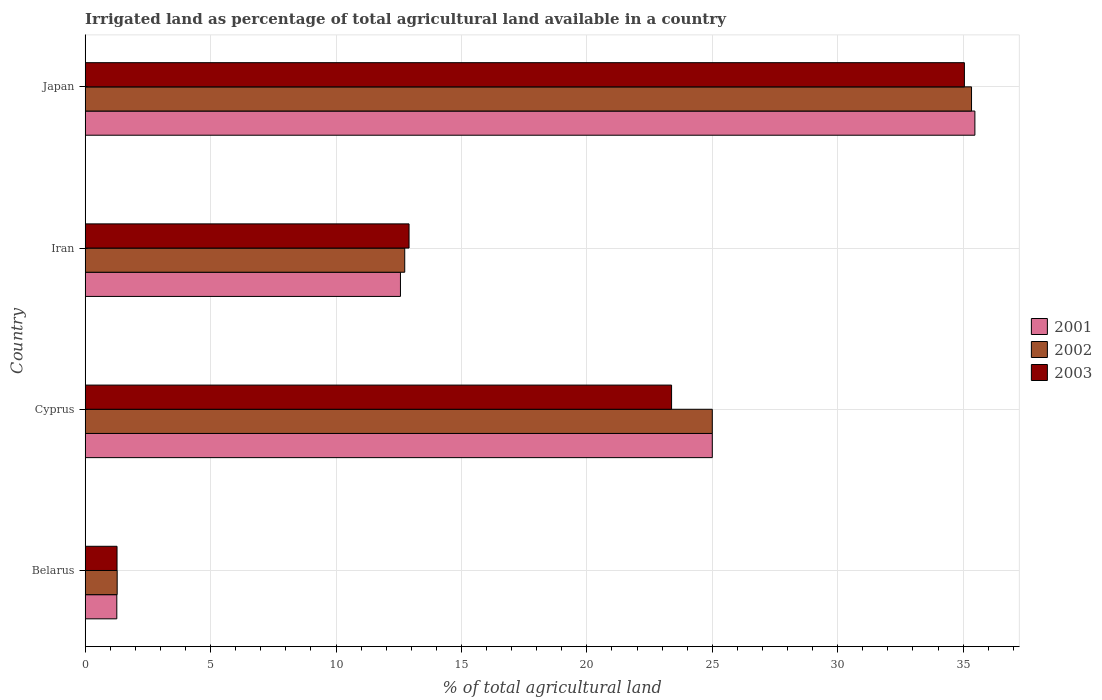How many bars are there on the 1st tick from the bottom?
Your answer should be very brief. 3. What is the label of the 2nd group of bars from the top?
Ensure brevity in your answer.  Iran. What is the percentage of irrigated land in 2001 in Belarus?
Provide a short and direct response. 1.26. Across all countries, what is the maximum percentage of irrigated land in 2001?
Make the answer very short. 35.47. Across all countries, what is the minimum percentage of irrigated land in 2001?
Give a very brief answer. 1.26. In which country was the percentage of irrigated land in 2003 maximum?
Ensure brevity in your answer.  Japan. In which country was the percentage of irrigated land in 2002 minimum?
Keep it short and to the point. Belarus. What is the total percentage of irrigated land in 2003 in the graph?
Ensure brevity in your answer.  72.61. What is the difference between the percentage of irrigated land in 2001 in Belarus and that in Japan?
Provide a succinct answer. -34.21. What is the difference between the percentage of irrigated land in 2001 in Belarus and the percentage of irrigated land in 2003 in Cyprus?
Provide a succinct answer. -22.12. What is the average percentage of irrigated land in 2003 per country?
Your response must be concise. 18.15. What is the difference between the percentage of irrigated land in 2002 and percentage of irrigated land in 2001 in Japan?
Your answer should be very brief. -0.13. What is the ratio of the percentage of irrigated land in 2002 in Cyprus to that in Japan?
Offer a very short reply. 0.71. Is the difference between the percentage of irrigated land in 2002 in Cyprus and Iran greater than the difference between the percentage of irrigated land in 2001 in Cyprus and Iran?
Offer a very short reply. No. What is the difference between the highest and the second highest percentage of irrigated land in 2001?
Give a very brief answer. 10.47. What is the difference between the highest and the lowest percentage of irrigated land in 2001?
Ensure brevity in your answer.  34.21. Is the sum of the percentage of irrigated land in 2001 in Cyprus and Iran greater than the maximum percentage of irrigated land in 2002 across all countries?
Keep it short and to the point. Yes. How many bars are there?
Your answer should be very brief. 12. What is the difference between two consecutive major ticks on the X-axis?
Your answer should be compact. 5. Where does the legend appear in the graph?
Your answer should be compact. Center right. How many legend labels are there?
Offer a very short reply. 3. How are the legend labels stacked?
Your answer should be very brief. Vertical. What is the title of the graph?
Your answer should be very brief. Irrigated land as percentage of total agricultural land available in a country. Does "1976" appear as one of the legend labels in the graph?
Your answer should be compact. No. What is the label or title of the X-axis?
Give a very brief answer. % of total agricultural land. What is the % of total agricultural land of 2001 in Belarus?
Give a very brief answer. 1.26. What is the % of total agricultural land of 2002 in Belarus?
Offer a very short reply. 1.27. What is the % of total agricultural land of 2003 in Belarus?
Give a very brief answer. 1.27. What is the % of total agricultural land in 2003 in Cyprus?
Ensure brevity in your answer.  23.38. What is the % of total agricultural land of 2001 in Iran?
Keep it short and to the point. 12.57. What is the % of total agricultural land of 2002 in Iran?
Give a very brief answer. 12.74. What is the % of total agricultural land of 2003 in Iran?
Give a very brief answer. 12.91. What is the % of total agricultural land of 2001 in Japan?
Your response must be concise. 35.47. What is the % of total agricultural land of 2002 in Japan?
Your answer should be very brief. 35.33. What is the % of total agricultural land of 2003 in Japan?
Keep it short and to the point. 35.05. Across all countries, what is the maximum % of total agricultural land of 2001?
Keep it short and to the point. 35.47. Across all countries, what is the maximum % of total agricultural land in 2002?
Make the answer very short. 35.33. Across all countries, what is the maximum % of total agricultural land in 2003?
Ensure brevity in your answer.  35.05. Across all countries, what is the minimum % of total agricultural land in 2001?
Your response must be concise. 1.26. Across all countries, what is the minimum % of total agricultural land of 2002?
Keep it short and to the point. 1.27. Across all countries, what is the minimum % of total agricultural land in 2003?
Your answer should be compact. 1.27. What is the total % of total agricultural land of 2001 in the graph?
Offer a very short reply. 74.3. What is the total % of total agricultural land of 2002 in the graph?
Make the answer very short. 74.35. What is the total % of total agricultural land in 2003 in the graph?
Your answer should be compact. 72.61. What is the difference between the % of total agricultural land in 2001 in Belarus and that in Cyprus?
Your response must be concise. -23.74. What is the difference between the % of total agricultural land in 2002 in Belarus and that in Cyprus?
Make the answer very short. -23.73. What is the difference between the % of total agricultural land in 2003 in Belarus and that in Cyprus?
Offer a terse response. -22.11. What is the difference between the % of total agricultural land in 2001 in Belarus and that in Iran?
Your answer should be very brief. -11.31. What is the difference between the % of total agricultural land of 2002 in Belarus and that in Iran?
Provide a succinct answer. -11.46. What is the difference between the % of total agricultural land in 2003 in Belarus and that in Iran?
Make the answer very short. -11.64. What is the difference between the % of total agricultural land in 2001 in Belarus and that in Japan?
Provide a succinct answer. -34.21. What is the difference between the % of total agricultural land in 2002 in Belarus and that in Japan?
Offer a terse response. -34.06. What is the difference between the % of total agricultural land of 2003 in Belarus and that in Japan?
Your response must be concise. -33.78. What is the difference between the % of total agricultural land in 2001 in Cyprus and that in Iran?
Give a very brief answer. 12.43. What is the difference between the % of total agricultural land of 2002 in Cyprus and that in Iran?
Provide a short and direct response. 12.26. What is the difference between the % of total agricultural land in 2003 in Cyprus and that in Iran?
Provide a short and direct response. 10.47. What is the difference between the % of total agricultural land of 2001 in Cyprus and that in Japan?
Offer a very short reply. -10.47. What is the difference between the % of total agricultural land of 2002 in Cyprus and that in Japan?
Offer a very short reply. -10.33. What is the difference between the % of total agricultural land of 2003 in Cyprus and that in Japan?
Provide a succinct answer. -11.67. What is the difference between the % of total agricultural land of 2001 in Iran and that in Japan?
Make the answer very short. -22.9. What is the difference between the % of total agricultural land of 2002 in Iran and that in Japan?
Keep it short and to the point. -22.6. What is the difference between the % of total agricultural land in 2003 in Iran and that in Japan?
Give a very brief answer. -22.14. What is the difference between the % of total agricultural land of 2001 in Belarus and the % of total agricultural land of 2002 in Cyprus?
Make the answer very short. -23.74. What is the difference between the % of total agricultural land of 2001 in Belarus and the % of total agricultural land of 2003 in Cyprus?
Your answer should be very brief. -22.12. What is the difference between the % of total agricultural land of 2002 in Belarus and the % of total agricultural land of 2003 in Cyprus?
Ensure brevity in your answer.  -22.1. What is the difference between the % of total agricultural land of 2001 in Belarus and the % of total agricultural land of 2002 in Iran?
Offer a terse response. -11.48. What is the difference between the % of total agricultural land in 2001 in Belarus and the % of total agricultural land in 2003 in Iran?
Ensure brevity in your answer.  -11.65. What is the difference between the % of total agricultural land in 2002 in Belarus and the % of total agricultural land in 2003 in Iran?
Ensure brevity in your answer.  -11.64. What is the difference between the % of total agricultural land of 2001 in Belarus and the % of total agricultural land of 2002 in Japan?
Your answer should be compact. -34.08. What is the difference between the % of total agricultural land in 2001 in Belarus and the % of total agricultural land in 2003 in Japan?
Provide a succinct answer. -33.79. What is the difference between the % of total agricultural land of 2002 in Belarus and the % of total agricultural land of 2003 in Japan?
Provide a succinct answer. -33.78. What is the difference between the % of total agricultural land in 2001 in Cyprus and the % of total agricultural land in 2002 in Iran?
Your answer should be compact. 12.26. What is the difference between the % of total agricultural land of 2001 in Cyprus and the % of total agricultural land of 2003 in Iran?
Ensure brevity in your answer.  12.09. What is the difference between the % of total agricultural land in 2002 in Cyprus and the % of total agricultural land in 2003 in Iran?
Keep it short and to the point. 12.09. What is the difference between the % of total agricultural land of 2001 in Cyprus and the % of total agricultural land of 2002 in Japan?
Give a very brief answer. -10.33. What is the difference between the % of total agricultural land of 2001 in Cyprus and the % of total agricultural land of 2003 in Japan?
Give a very brief answer. -10.05. What is the difference between the % of total agricultural land in 2002 in Cyprus and the % of total agricultural land in 2003 in Japan?
Your answer should be compact. -10.05. What is the difference between the % of total agricultural land in 2001 in Iran and the % of total agricultural land in 2002 in Japan?
Your answer should be very brief. -22.77. What is the difference between the % of total agricultural land in 2001 in Iran and the % of total agricultural land in 2003 in Japan?
Your answer should be compact. -22.48. What is the difference between the % of total agricultural land of 2002 in Iran and the % of total agricultural land of 2003 in Japan?
Provide a short and direct response. -22.31. What is the average % of total agricultural land of 2001 per country?
Your answer should be compact. 18.57. What is the average % of total agricultural land of 2002 per country?
Your response must be concise. 18.59. What is the average % of total agricultural land in 2003 per country?
Give a very brief answer. 18.15. What is the difference between the % of total agricultural land in 2001 and % of total agricultural land in 2002 in Belarus?
Your answer should be very brief. -0.01. What is the difference between the % of total agricultural land in 2001 and % of total agricultural land in 2003 in Belarus?
Provide a succinct answer. -0.01. What is the difference between the % of total agricultural land in 2002 and % of total agricultural land in 2003 in Belarus?
Provide a succinct answer. 0.01. What is the difference between the % of total agricultural land of 2001 and % of total agricultural land of 2003 in Cyprus?
Ensure brevity in your answer.  1.62. What is the difference between the % of total agricultural land in 2002 and % of total agricultural land in 2003 in Cyprus?
Your answer should be very brief. 1.62. What is the difference between the % of total agricultural land of 2001 and % of total agricultural land of 2002 in Iran?
Make the answer very short. -0.17. What is the difference between the % of total agricultural land of 2001 and % of total agricultural land of 2003 in Iran?
Keep it short and to the point. -0.34. What is the difference between the % of total agricultural land of 2002 and % of total agricultural land of 2003 in Iran?
Keep it short and to the point. -0.17. What is the difference between the % of total agricultural land of 2001 and % of total agricultural land of 2002 in Japan?
Provide a short and direct response. 0.13. What is the difference between the % of total agricultural land in 2001 and % of total agricultural land in 2003 in Japan?
Give a very brief answer. 0.42. What is the difference between the % of total agricultural land of 2002 and % of total agricultural land of 2003 in Japan?
Offer a terse response. 0.28. What is the ratio of the % of total agricultural land of 2001 in Belarus to that in Cyprus?
Keep it short and to the point. 0.05. What is the ratio of the % of total agricultural land in 2002 in Belarus to that in Cyprus?
Your answer should be very brief. 0.05. What is the ratio of the % of total agricultural land of 2003 in Belarus to that in Cyprus?
Keep it short and to the point. 0.05. What is the ratio of the % of total agricultural land of 2001 in Belarus to that in Iran?
Your answer should be compact. 0.1. What is the ratio of the % of total agricultural land of 2003 in Belarus to that in Iran?
Provide a short and direct response. 0.1. What is the ratio of the % of total agricultural land in 2001 in Belarus to that in Japan?
Offer a terse response. 0.04. What is the ratio of the % of total agricultural land of 2002 in Belarus to that in Japan?
Provide a succinct answer. 0.04. What is the ratio of the % of total agricultural land in 2003 in Belarus to that in Japan?
Provide a succinct answer. 0.04. What is the ratio of the % of total agricultural land of 2001 in Cyprus to that in Iran?
Keep it short and to the point. 1.99. What is the ratio of the % of total agricultural land in 2002 in Cyprus to that in Iran?
Ensure brevity in your answer.  1.96. What is the ratio of the % of total agricultural land of 2003 in Cyprus to that in Iran?
Offer a very short reply. 1.81. What is the ratio of the % of total agricultural land in 2001 in Cyprus to that in Japan?
Offer a very short reply. 0.7. What is the ratio of the % of total agricultural land of 2002 in Cyprus to that in Japan?
Your response must be concise. 0.71. What is the ratio of the % of total agricultural land of 2003 in Cyprus to that in Japan?
Provide a succinct answer. 0.67. What is the ratio of the % of total agricultural land of 2001 in Iran to that in Japan?
Offer a very short reply. 0.35. What is the ratio of the % of total agricultural land of 2002 in Iran to that in Japan?
Your answer should be very brief. 0.36. What is the ratio of the % of total agricultural land of 2003 in Iran to that in Japan?
Ensure brevity in your answer.  0.37. What is the difference between the highest and the second highest % of total agricultural land of 2001?
Offer a very short reply. 10.47. What is the difference between the highest and the second highest % of total agricultural land of 2002?
Give a very brief answer. 10.33. What is the difference between the highest and the second highest % of total agricultural land of 2003?
Offer a very short reply. 11.67. What is the difference between the highest and the lowest % of total agricultural land in 2001?
Offer a terse response. 34.21. What is the difference between the highest and the lowest % of total agricultural land of 2002?
Your answer should be very brief. 34.06. What is the difference between the highest and the lowest % of total agricultural land in 2003?
Your answer should be compact. 33.78. 